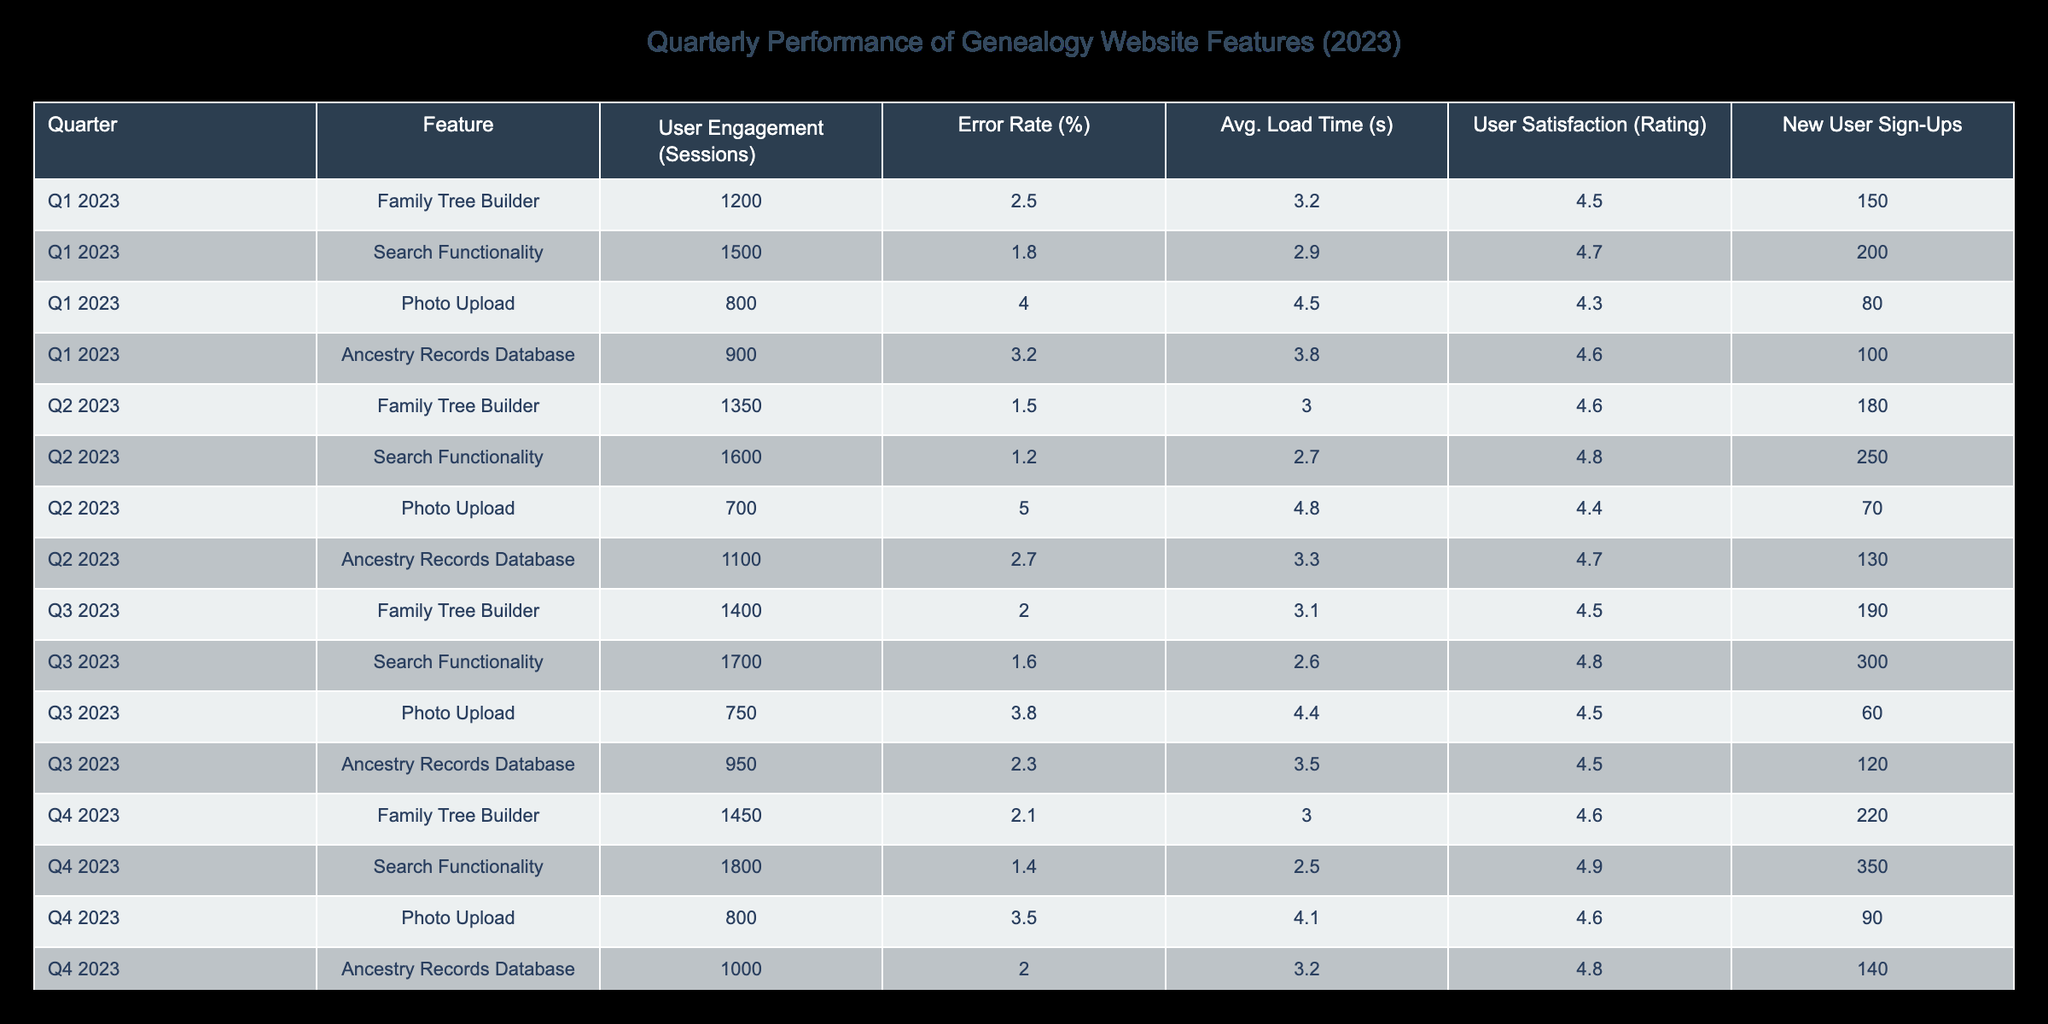What feature had the highest user engagement in Q4 2023? In Q4 2023, the table shows that the Search Functionality had 1800 user engagement sessions, which is higher than any other feature in that quarter.
Answer: Search Functionality What was the average error rate for the Photo Upload feature across all quarters? To find the average error rate for Photo Upload, we take the values from all quarters: 4.0, 5.0, 3.8, and 3.5. Summing those gives 16.3, and dividing by 4 gives an average of 4.075.
Answer: 4.075 Which feature had the lowest user satisfaction rating in Q2 2023? In Q2 2023, the Photo Upload feature had the lowest satisfaction rating of 4.4, as all other ratings are higher.
Answer: Photo Upload Did the Family Tree Builder show improvement in user engagement from Q1 to Q4 2023? In Q1 2023, the Family Tree Builder had 1200 user engagement sessions, and by Q4 2023, this increased to 1450. Since this is an increase, we can conclude that there was improvement in user engagement.
Answer: Yes What is the total number of new user sign-ups for the Search Functionality over the four quarters? Summing up the new user sign-ups for Search Functionality across all four quarters: 200 (Q1) + 250 (Q2) + 300 (Q3) + 350 (Q4) equals 1100 total new user sign-ups.
Answer: 1100 How did the average load time for the Ancestry Records Database change from Q1 to Q4 2023? In Q1 2023, the average load time was 3.8 seconds, which decreased to 3.2 seconds by Q4 2023. This indicates an improvement in loading time.
Answer: Decreased Which feature had the highest error rate overall in Q3 2023? In Q3 2023, the Photo Upload feature had an error rate of 3.8%, which was the highest of all features in that quarter.
Answer: Photo Upload What is the median user satisfaction rating for the Family Tree Builder across all quarters? The satisfaction ratings for Family Tree Builder across the four quarters are 4.5, 4.6, 4.5, and 4.6. Sorting these gives 4.5, 4.5, 4.6, 4.6. The median is calculated as the average of the two middle values: (4.5 + 4.6) / 2 = 4.55.
Answer: 4.55 Which feature had the most significant drop in new user sign-ups from Q2 to Q3 2023? Analyzing the new user sign-ups: Family Tree Builder had 180 in Q2 and dropped to 190 in Q3, Photo Upload dropped from 70 to 60. The Search Functionality increased, while Ancestry Records Database decreased from 130 to 120. The only drop comes from Photo Upload.
Answer: Photo Upload 